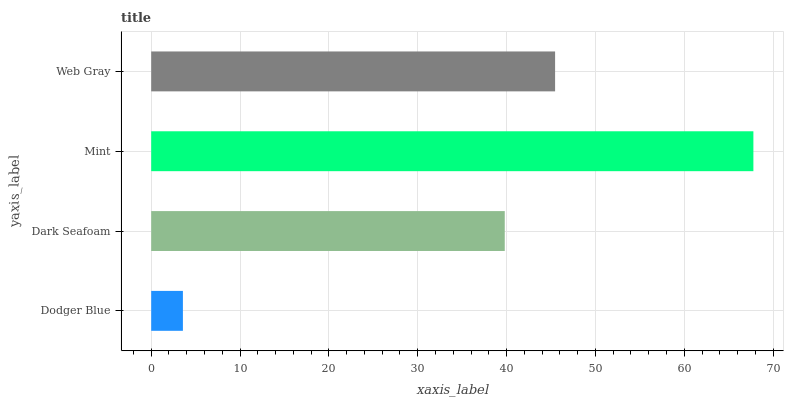Is Dodger Blue the minimum?
Answer yes or no. Yes. Is Mint the maximum?
Answer yes or no. Yes. Is Dark Seafoam the minimum?
Answer yes or no. No. Is Dark Seafoam the maximum?
Answer yes or no. No. Is Dark Seafoam greater than Dodger Blue?
Answer yes or no. Yes. Is Dodger Blue less than Dark Seafoam?
Answer yes or no. Yes. Is Dodger Blue greater than Dark Seafoam?
Answer yes or no. No. Is Dark Seafoam less than Dodger Blue?
Answer yes or no. No. Is Web Gray the high median?
Answer yes or no. Yes. Is Dark Seafoam the low median?
Answer yes or no. Yes. Is Mint the high median?
Answer yes or no. No. Is Mint the low median?
Answer yes or no. No. 